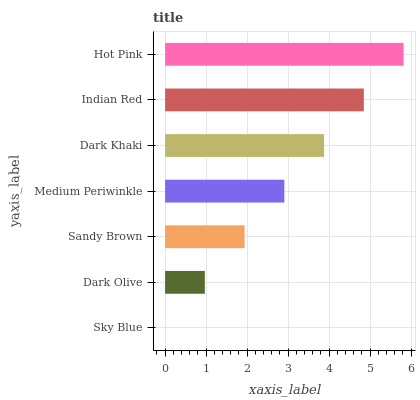Is Sky Blue the minimum?
Answer yes or no. Yes. Is Hot Pink the maximum?
Answer yes or no. Yes. Is Dark Olive the minimum?
Answer yes or no. No. Is Dark Olive the maximum?
Answer yes or no. No. Is Dark Olive greater than Sky Blue?
Answer yes or no. Yes. Is Sky Blue less than Dark Olive?
Answer yes or no. Yes. Is Sky Blue greater than Dark Olive?
Answer yes or no. No. Is Dark Olive less than Sky Blue?
Answer yes or no. No. Is Medium Periwinkle the high median?
Answer yes or no. Yes. Is Medium Periwinkle the low median?
Answer yes or no. Yes. Is Sandy Brown the high median?
Answer yes or no. No. Is Sky Blue the low median?
Answer yes or no. No. 